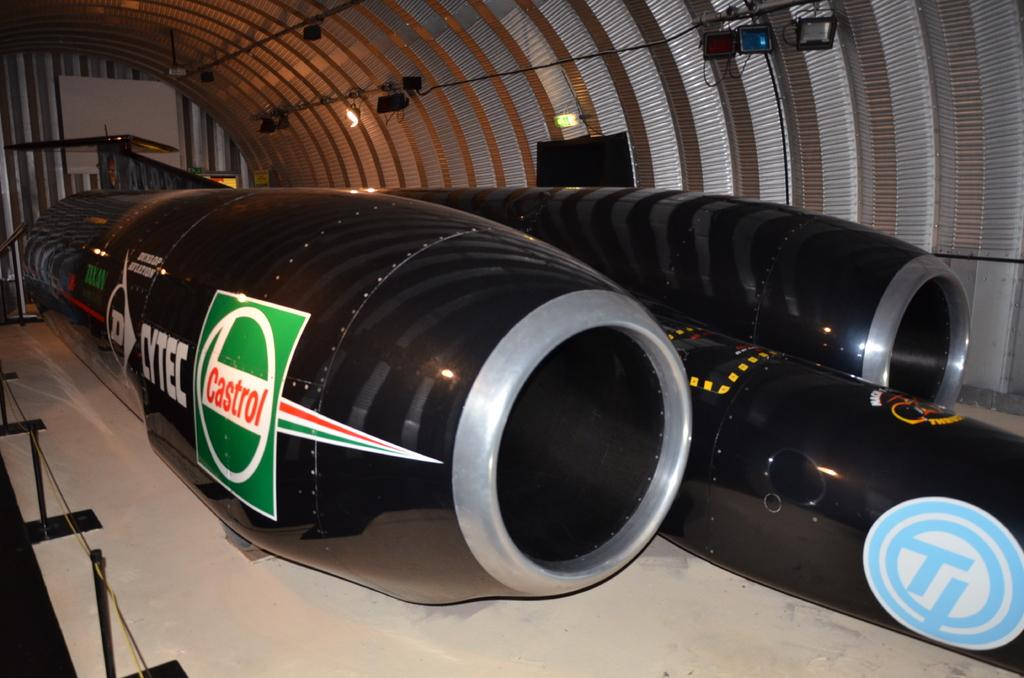<image>
Write a terse but informative summary of the picture. a green sign on an engine that says Castrol 